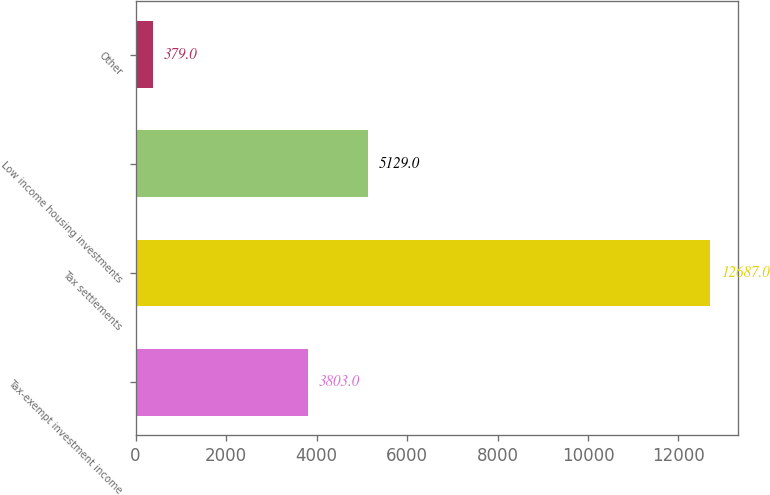Convert chart. <chart><loc_0><loc_0><loc_500><loc_500><bar_chart><fcel>Tax-exempt investment income<fcel>Tax settlements<fcel>Low income housing investments<fcel>Other<nl><fcel>3803<fcel>12687<fcel>5129<fcel>379<nl></chart> 